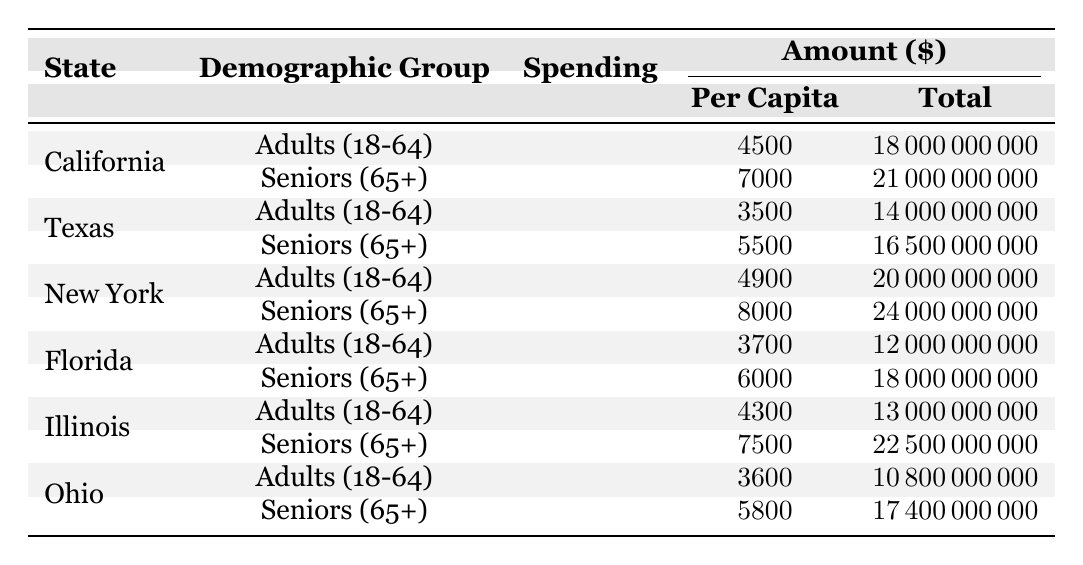What is the total spending on healthcare for seniors in California? According to the table, the total spending for seniors (65+) in California is listed as $21,000,000,000.
Answer: 21000000000 Which demographic group has the highest per capita spending in New York? The table shows that seniors (65+) in New York have a per capita spending of $8,000, which is higher than the $4,900 for adults (18-64).
Answer: Seniors (65+) What is the average per capita spending for adults (18-64) across all states? The per capita spending for adults is $4,500 (California) + $3,500 (Texas) + $4,900 (New York) + $3,700 (Florida) + $4,300 (Illinois) + $3,600 (Ohio) = $24,500. Dividing by 6 states gives an average of $4,083.33.
Answer: 4083.33 Is the total spending for seniors (65+) in Texas greater than in Florida? Texas has a total spending of $16,500,000,000 for seniors, while Florida has a total spending of $18,000,000,000. Since $16,500,000,000 < $18,000,000,000, the statement is false.
Answer: No What is the difference in per capita spending between adults (18-64) and seniors (65+) in Illinois? The per capita spending for seniors (65+) in Illinois is $7,500, while adults (18-64) spend $4,300. The difference is $7,500 - $4,300 = $3,200.
Answer: 3200 Which state spends the least per capita on healthcare for adults (18-64)? From the table, Texas spends $3,500, which is lower than the other states for that demographic.
Answer: Texas What is the combined total spending for seniors (65+) in all states? Total spending for seniors is: California $21,000,000,000 + Texas $16,500,000,000 + New York $24,000,000,000 + Florida $18,000,000,000 + Illinois $22,500,000,000 + Ohio $17,400,000,000 = $119,400,000,000.
Answer: 119400000000 What state has the highest per capita healthcare spending for seniors? The table indicates that New York has the highest per capita spending for seniors at $8,000.
Answer: New York What is the total healthcare spending for adults (18-64) across all states? Total spending for adults is $18,000,000,000 (California) + $14,000,000,000 (Texas) + $20,000,000,000 (New York) + $12,000,000,000 (Florida) + $13,000,000,000 (Illinois) + $10,800,000,000 (Ohio) = $88,800,000,000.
Answer: 88800000000 Is the per capita spending for seniors in Ohio more than in Illinois? The per capita spending is $5,800 in Ohio and $7,500 in Illinois. Since $5,800 < $7,500, the answer is no.
Answer: No 